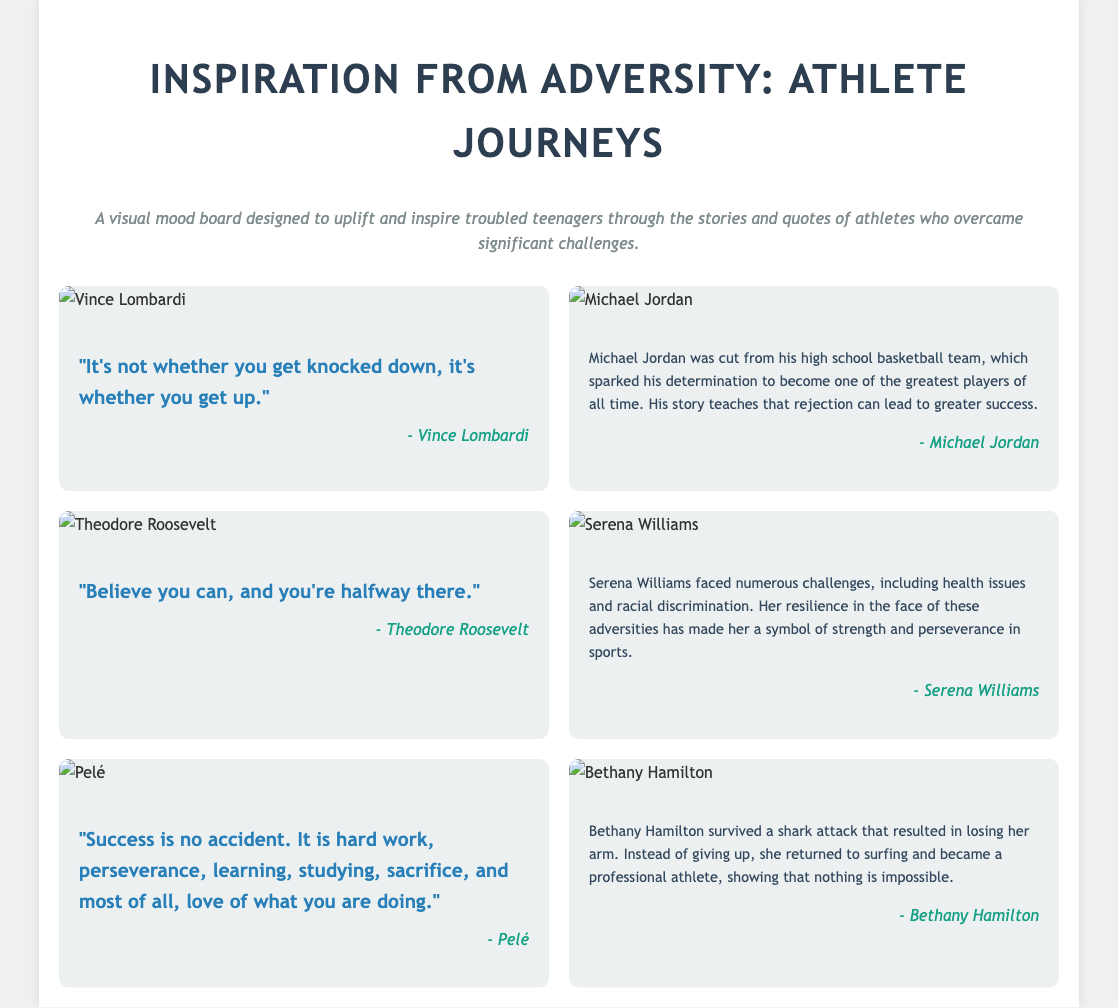What is the title of the document? The title appears at the top of the document and summarizes its purpose.
Answer: Inspiration from Adversity: Athlete Journeys How many athlete stories are featured? There are six elements in the mood board, each representing an athlete with a quote or story.
Answer: 6 Who said, "It's not whether you get knocked down, it's whether you get up"? This quote is attributed to an athlete featured in the document, giving insight into resilience.
Answer: Vince Lombardi What significant challenge did Michael Jordan face? The document provides specific challenges faced by athletes, particularly Michael Jordan after being cut from a team.
Answer: Cut from high school basketball team What lesson does Bethany Hamilton’s story illustrate? The story highlighted demonstrates overcoming adversity, as Hamilton returned to her passion despite significant challenges.
Answer: Nothing is impossible Which athlete is associated with losing an arm in a shark attack? This detail connects the athlete's story to a real-life event that showcases remarkable resilience.
Answer: Bethany Hamilton What color is the document's background? The background color of the document contributes to its overall aesthetic, which enhances readability.
Answer: #f0f0f0 What is the main purpose of this visual mood board? The document outlines the overarching goal of providing inspiration through athlete stories.
Answer: Uplift and inspire troubled teenagers Who is the attributed author of the quote, "Success is no accident"? This detail identifies the source of the motivational quote presented within the mood board.
Answer: Pelé 